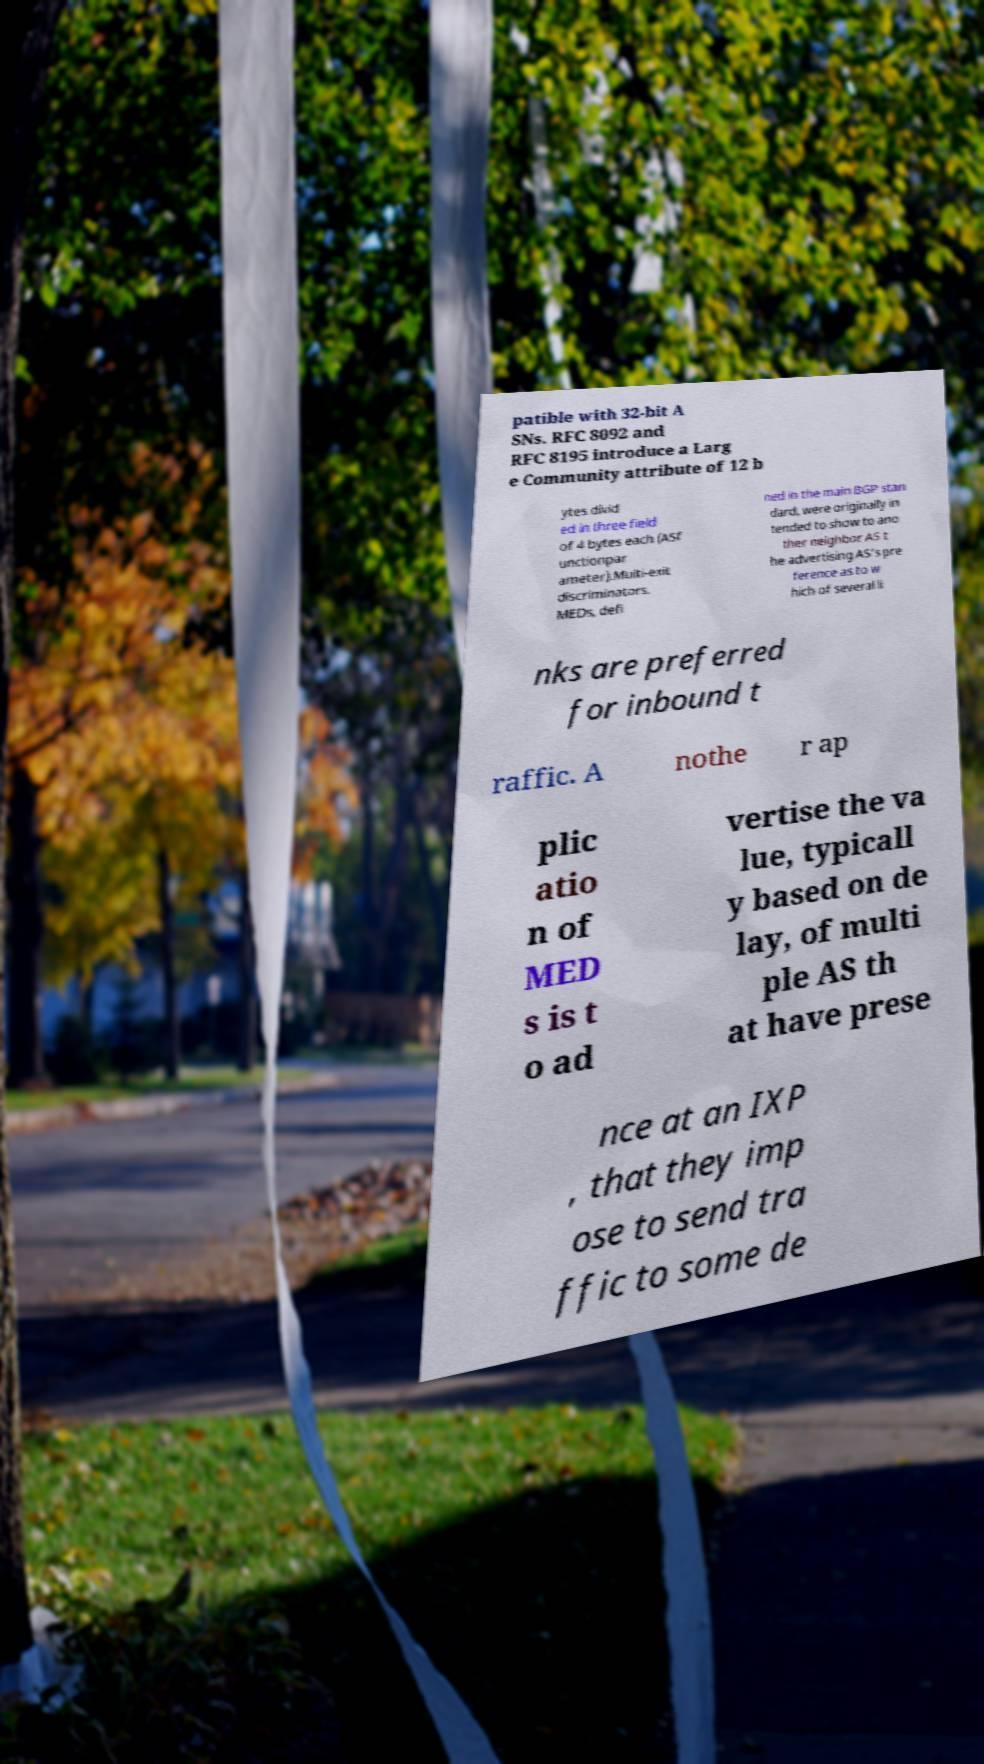I need the written content from this picture converted into text. Can you do that? patible with 32-bit A SNs. RFC 8092 and RFC 8195 introduce a Larg e Community attribute of 12 b ytes divid ed in three field of 4 bytes each (ASf unctionpar ameter).Multi-exit discriminators. MEDs, defi ned in the main BGP stan dard, were originally in tended to show to ano ther neighbor AS t he advertising AS's pre ference as to w hich of several li nks are preferred for inbound t raffic. A nothe r ap plic atio n of MED s is t o ad vertise the va lue, typicall y based on de lay, of multi ple AS th at have prese nce at an IXP , that they imp ose to send tra ffic to some de 